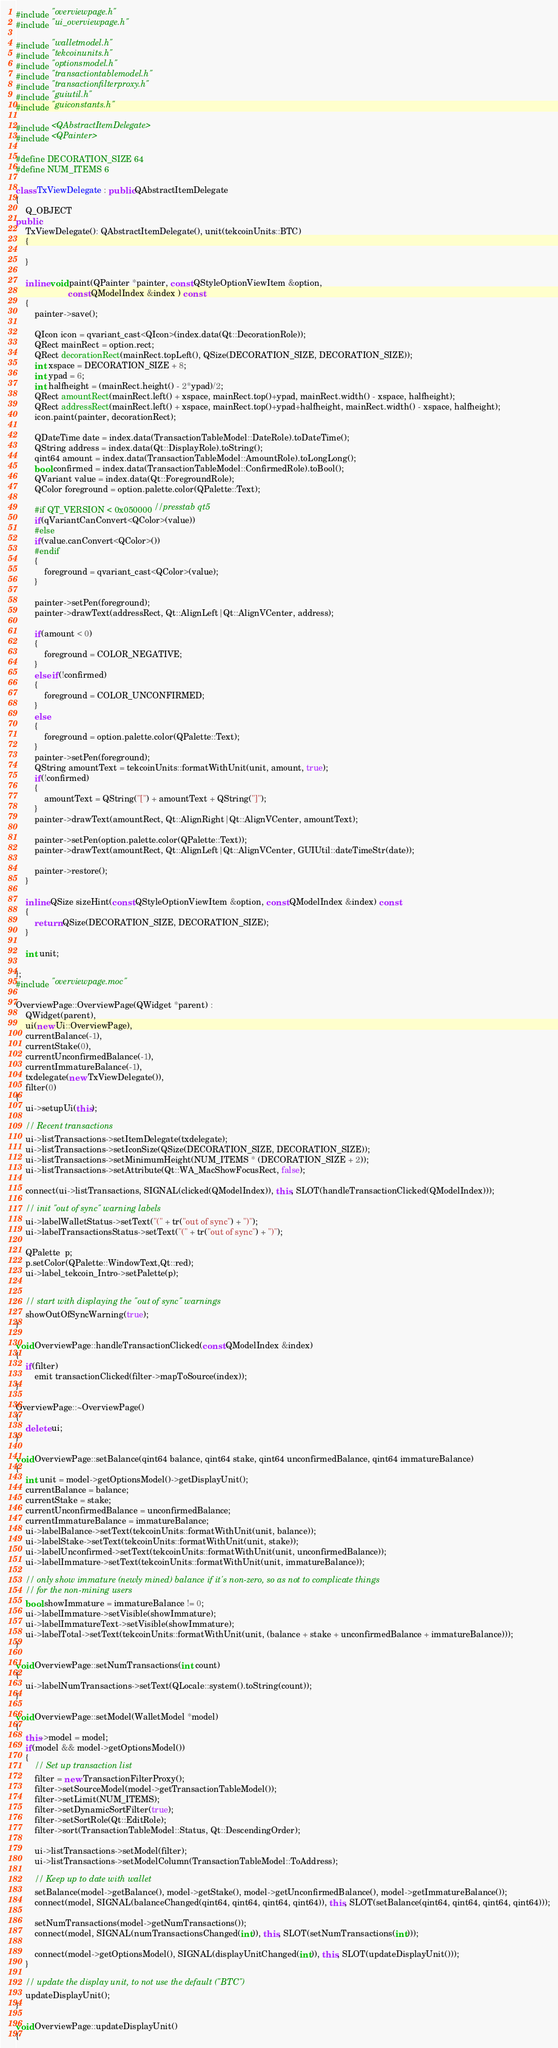Convert code to text. <code><loc_0><loc_0><loc_500><loc_500><_C++_>#include "overviewpage.h"
#include "ui_overviewpage.h"

#include "walletmodel.h"
#include "tekcoinunits.h"
#include "optionsmodel.h"
#include "transactiontablemodel.h"
#include "transactionfilterproxy.h"
#include "guiutil.h"
#include "guiconstants.h"

#include <QAbstractItemDelegate>
#include <QPainter>

#define DECORATION_SIZE 64
#define NUM_ITEMS 6

class TxViewDelegate : public QAbstractItemDelegate
{
    Q_OBJECT
public:
    TxViewDelegate(): QAbstractItemDelegate(), unit(tekcoinUnits::BTC)
    {

    }

    inline void paint(QPainter *painter, const QStyleOptionViewItem &option,
                      const QModelIndex &index ) const
    {
        painter->save();

        QIcon icon = qvariant_cast<QIcon>(index.data(Qt::DecorationRole));
        QRect mainRect = option.rect;
        QRect decorationRect(mainRect.topLeft(), QSize(DECORATION_SIZE, DECORATION_SIZE));
        int xspace = DECORATION_SIZE + 8;
        int ypad = 6;
        int halfheight = (mainRect.height() - 2*ypad)/2;
        QRect amountRect(mainRect.left() + xspace, mainRect.top()+ypad, mainRect.width() - xspace, halfheight);
        QRect addressRect(mainRect.left() + xspace, mainRect.top()+ypad+halfheight, mainRect.width() - xspace, halfheight);
        icon.paint(painter, decorationRect);

        QDateTime date = index.data(TransactionTableModel::DateRole).toDateTime();
        QString address = index.data(Qt::DisplayRole).toString();
        qint64 amount = index.data(TransactionTableModel::AmountRole).toLongLong();
        bool confirmed = index.data(TransactionTableModel::ConfirmedRole).toBool();
        QVariant value = index.data(Qt::ForegroundRole);
        QColor foreground = option.palette.color(QPalette::Text);
		
        #if QT_VERSION < 0x050000 //presstab qt5
        if(qVariantCanConvert<QColor>(value))
		#else
        if(value.canConvert<QColor>())
		#endif
        {
            foreground = qvariant_cast<QColor>(value);
        }

        painter->setPen(foreground);
        painter->drawText(addressRect, Qt::AlignLeft|Qt::AlignVCenter, address);

        if(amount < 0)
        {
            foreground = COLOR_NEGATIVE;
        }
        else if(!confirmed)
        {
            foreground = COLOR_UNCONFIRMED;
        }
        else
        {
            foreground = option.palette.color(QPalette::Text);
        }
        painter->setPen(foreground);
        QString amountText = tekcoinUnits::formatWithUnit(unit, amount, true);
        if(!confirmed)
        {
            amountText = QString("[") + amountText + QString("]");
        }
        painter->drawText(amountRect, Qt::AlignRight|Qt::AlignVCenter, amountText);

        painter->setPen(option.palette.color(QPalette::Text));
        painter->drawText(amountRect, Qt::AlignLeft|Qt::AlignVCenter, GUIUtil::dateTimeStr(date));

        painter->restore();
    }

    inline QSize sizeHint(const QStyleOptionViewItem &option, const QModelIndex &index) const
    {
        return QSize(DECORATION_SIZE, DECORATION_SIZE);
    }

    int unit;

};
#include "overviewpage.moc"

OverviewPage::OverviewPage(QWidget *parent) :
    QWidget(parent),
    ui(new Ui::OverviewPage),
    currentBalance(-1),
    currentStake(0),
    currentUnconfirmedBalance(-1),
    currentImmatureBalance(-1),
    txdelegate(new TxViewDelegate()),
    filter(0)
{
    ui->setupUi(this);

    // Recent transactions
    ui->listTransactions->setItemDelegate(txdelegate);
    ui->listTransactions->setIconSize(QSize(DECORATION_SIZE, DECORATION_SIZE));
    ui->listTransactions->setMinimumHeight(NUM_ITEMS * (DECORATION_SIZE + 2));
    ui->listTransactions->setAttribute(Qt::WA_MacShowFocusRect, false);

    connect(ui->listTransactions, SIGNAL(clicked(QModelIndex)), this, SLOT(handleTransactionClicked(QModelIndex)));

    // init "out of sync" warning labels
    ui->labelWalletStatus->setText("(" + tr("out of sync") + ")");
    ui->labelTransactionsStatus->setText("(" + tr("out of sync") + ")");

    QPalette  p;
    p.setColor(QPalette::WindowText,Qt::red);
    ui->label_tekcoin_Intro->setPalette(p);


    // start with displaying the "out of sync" warnings
    showOutOfSyncWarning(true);
}

void OverviewPage::handleTransactionClicked(const QModelIndex &index)
{
    if(filter)
        emit transactionClicked(filter->mapToSource(index));
}

OverviewPage::~OverviewPage()
{
    delete ui;
}

void OverviewPage::setBalance(qint64 balance, qint64 stake, qint64 unconfirmedBalance, qint64 immatureBalance)
{
    int unit = model->getOptionsModel()->getDisplayUnit();
    currentBalance = balance;
    currentStake = stake;
    currentUnconfirmedBalance = unconfirmedBalance;
    currentImmatureBalance = immatureBalance;
    ui->labelBalance->setText(tekcoinUnits::formatWithUnit(unit, balance));
    ui->labelStake->setText(tekcoinUnits::formatWithUnit(unit, stake));
    ui->labelUnconfirmed->setText(tekcoinUnits::formatWithUnit(unit, unconfirmedBalance));
    ui->labelImmature->setText(tekcoinUnits::formatWithUnit(unit, immatureBalance));

    // only show immature (newly mined) balance if it's non-zero, so as not to complicate things
    // for the non-mining users
    bool showImmature = immatureBalance != 0;
    ui->labelImmature->setVisible(showImmature);
    ui->labelImmatureText->setVisible(showImmature);
    ui->labelTotal->setText(tekcoinUnits::formatWithUnit(unit, (balance + stake + unconfirmedBalance + immatureBalance)));
}

void OverviewPage::setNumTransactions(int count)
{
    ui->labelNumTransactions->setText(QLocale::system().toString(count));
}

void OverviewPage::setModel(WalletModel *model)
{
    this->model = model;
    if(model && model->getOptionsModel())
    {
        // Set up transaction list
        filter = new TransactionFilterProxy();
        filter->setSourceModel(model->getTransactionTableModel());
        filter->setLimit(NUM_ITEMS);
        filter->setDynamicSortFilter(true);
        filter->setSortRole(Qt::EditRole);
        filter->sort(TransactionTableModel::Status, Qt::DescendingOrder);

        ui->listTransactions->setModel(filter);
        ui->listTransactions->setModelColumn(TransactionTableModel::ToAddress);

        // Keep up to date with wallet
        setBalance(model->getBalance(), model->getStake(), model->getUnconfirmedBalance(), model->getImmatureBalance());
        connect(model, SIGNAL(balanceChanged(qint64, qint64, qint64, qint64)), this, SLOT(setBalance(qint64, qint64, qint64, qint64)));

        setNumTransactions(model->getNumTransactions());
        connect(model, SIGNAL(numTransactionsChanged(int)), this, SLOT(setNumTransactions(int)));

        connect(model->getOptionsModel(), SIGNAL(displayUnitChanged(int)), this, SLOT(updateDisplayUnit()));
    }

    // update the display unit, to not use the default ("BTC")
    updateDisplayUnit();
}

void OverviewPage::updateDisplayUnit()
{</code> 